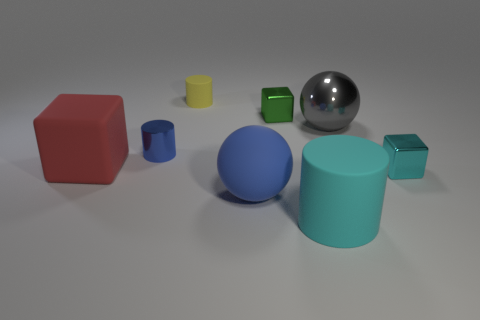What material is the red thing that is the same size as the cyan matte cylinder?
Offer a terse response. Rubber. There is a gray object; what shape is it?
Ensure brevity in your answer.  Sphere. How many gray things are either cubes or big spheres?
Your answer should be compact. 1. The yellow thing that is the same material as the red object is what size?
Ensure brevity in your answer.  Small. Does the blue object right of the tiny yellow rubber cylinder have the same material as the tiny block that is on the right side of the gray ball?
Your answer should be compact. No. How many balls are either green shiny objects or large rubber things?
Give a very brief answer. 1. There is a matte sphere to the left of the thing that is to the right of the large gray object; how many things are in front of it?
Provide a short and direct response. 1. There is another big object that is the same shape as the blue rubber object; what is it made of?
Provide a succinct answer. Metal. What is the color of the tiny thing to the right of the big cyan rubber thing?
Keep it short and to the point. Cyan. Is the cyan cube made of the same material as the block that is on the left side of the yellow cylinder?
Provide a succinct answer. No. 